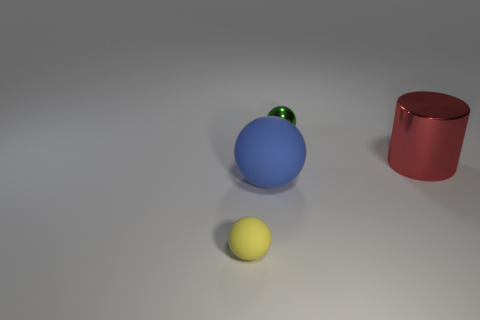There is a rubber sphere that is to the left of the big blue matte sphere; are there any tiny yellow rubber spheres that are behind it? no 